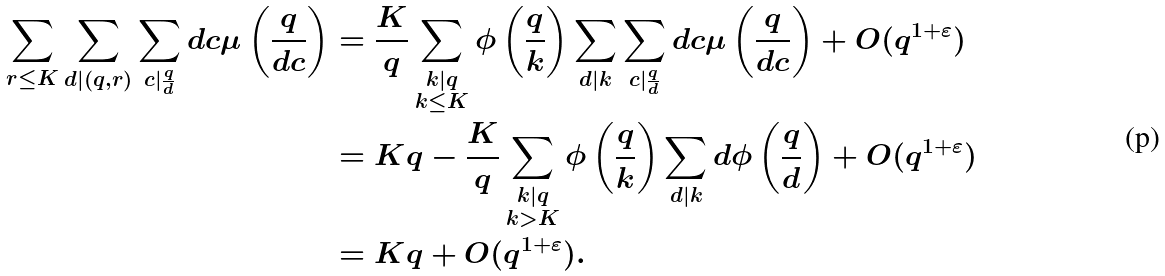<formula> <loc_0><loc_0><loc_500><loc_500>\sum _ { r \leq K } \sum _ { d | ( q , r ) } \sum _ { c | \frac { q } { d } } d c \mu \left ( \frac { q } { d c } \right ) & = \frac { K } { q } \sum _ { \substack { k | q \\ k \leq K } } \phi \left ( \frac { q } { k } \right ) \sum _ { d | k } \sum _ { c | \frac { q } { d } } d c \mu \left ( \frac { q } { d c } \right ) + O ( q ^ { 1 + \varepsilon } ) \\ & = K q - \frac { K } { q } \sum _ { \substack { k | q \\ k > K } } \phi \left ( \frac { q } { k } \right ) \sum _ { d | k } d \phi \left ( \frac { q } { d } \right ) + O ( q ^ { 1 + \varepsilon } ) \\ & = K q + O ( q ^ { 1 + \varepsilon } ) .</formula> 